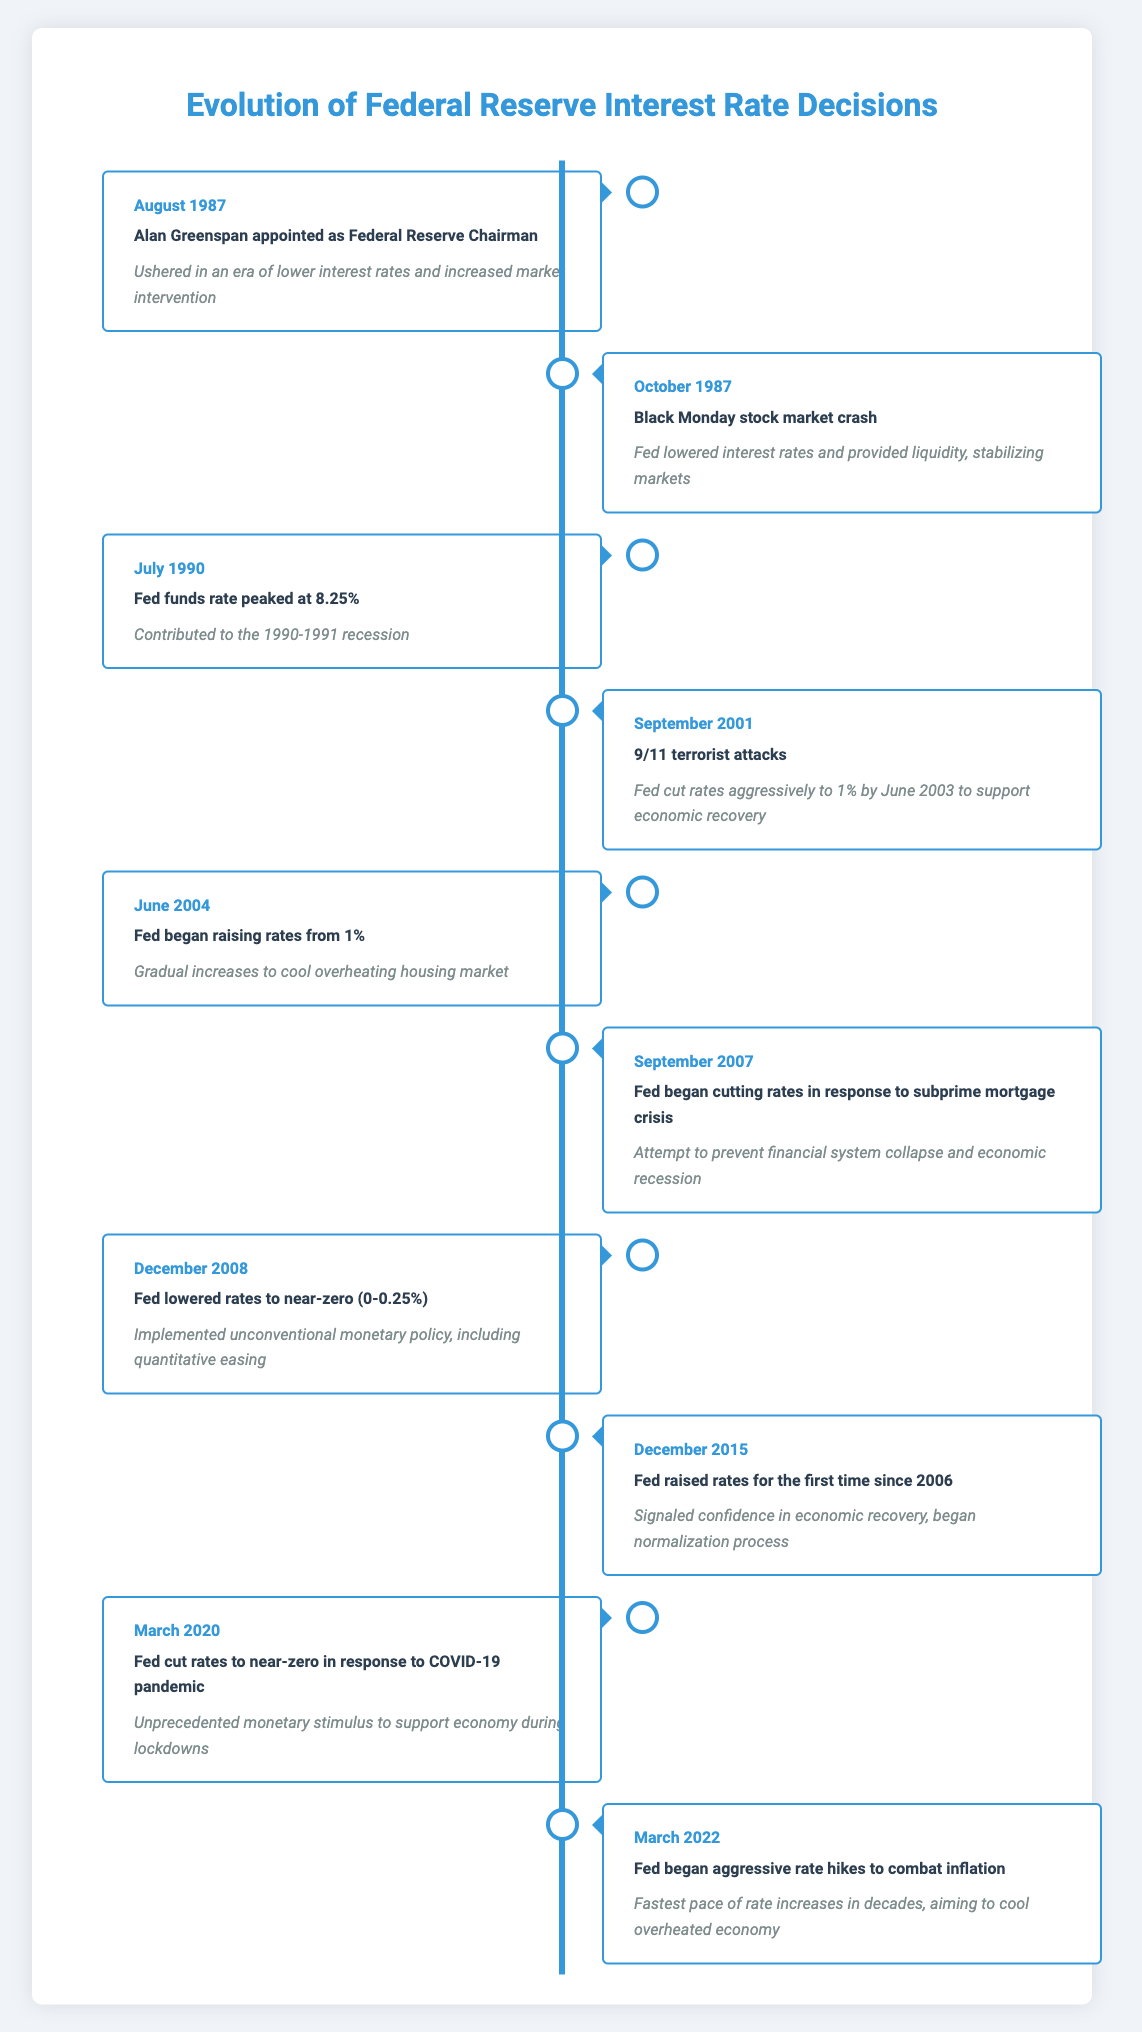What event marked Alan Greenspan's appointment as Federal Reserve Chairman? The table indicates that Alan Greenspan was appointed as Federal Reserve Chairman in August 1987. This event is linked to ushering in an era of lower interest rates and increased market intervention.
Answer: Alan Greenspan appointed as Federal Reserve Chairman What was the impact of the Fed's actions in response to the October 1987 stock market crash? According to the timeline, following the Black Monday stock market crash, the Federal Reserve lowered interest rates and provided liquidity to stabilize the markets.
Answer: Fed lowered interest rates and provided liquidity What was the highest Fed funds rate recorded in July 1990? The table specifically states that the Fed funds rate peaked at 8.25% in July 1990, contributing to the 1990-1991 recession.
Answer: 8.25% In which year did the Fed begin to raise interest rates from 1%? The timeline shows that the Fed began raising rates from 1% in June 2004 as part of their strategy to cool the overheating housing market.
Answer: June 2004 Did the Fed cut rates following the events of September 11, 2001? Yes, the table confirms that the Fed cut rates aggressively to 1% by June 2003 in response to the 9/11 terrorist attacks, supporting economic recovery.
Answer: Yes What was the time gap between Alan Greenspan's appointment and the Fed's decision to lower rates to near-zero in December 2008? From August 1987 to December 2008 is a time span of over 21 years. This period saw various economic challenges, leading to significant monetary policy shifts, culminating in the Fed's near-zero rates approach.
Answer: 21 years What was the Fed's response during the March 2020 COVID-19 pandemic? In March 2020, the Fed cut rates to near-zero in response to the pandemic, indicating an unprecedented monetary stimulus effort to support the economy during the lockdowns.
Answer: Cut rates to near-zero How many times did the Fed cut rates in the timeline provided? The timeline lists several events where the Fed cut rates: October 1987, September 2007, December 2008, and March 2020. Thus, the Fed cut rates a total of four times during the indicated periods.
Answer: Four times What was the significance of the Fed's rate hikes that began in March 2022? The timeline notes that the Fed began aggressive rate hikes in March 2022 to combat inflation, marking the fastest pace of rate increases in decades, which aimed to cool an overheated economy.
Answer: Fastest pace of rate increases in decades 